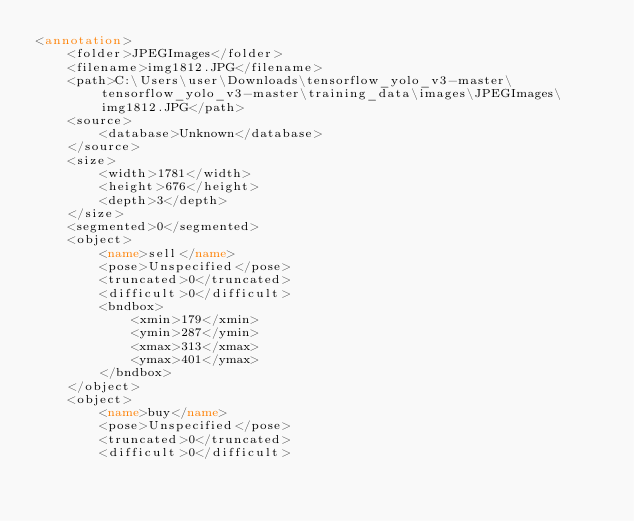Convert code to text. <code><loc_0><loc_0><loc_500><loc_500><_XML_><annotation>
	<folder>JPEGImages</folder>
	<filename>img1812.JPG</filename>
	<path>C:\Users\user\Downloads\tensorflow_yolo_v3-master\tensorflow_yolo_v3-master\training_data\images\JPEGImages\img1812.JPG</path>
	<source>
		<database>Unknown</database>
	</source>
	<size>
		<width>1781</width>
		<height>676</height>
		<depth>3</depth>
	</size>
	<segmented>0</segmented>
	<object>
		<name>sell</name>
		<pose>Unspecified</pose>
		<truncated>0</truncated>
		<difficult>0</difficult>
		<bndbox>
			<xmin>179</xmin>
			<ymin>287</ymin>
			<xmax>313</xmax>
			<ymax>401</ymax>
		</bndbox>
	</object>
	<object>
		<name>buy</name>
		<pose>Unspecified</pose>
		<truncated>0</truncated>
		<difficult>0</difficult></code> 